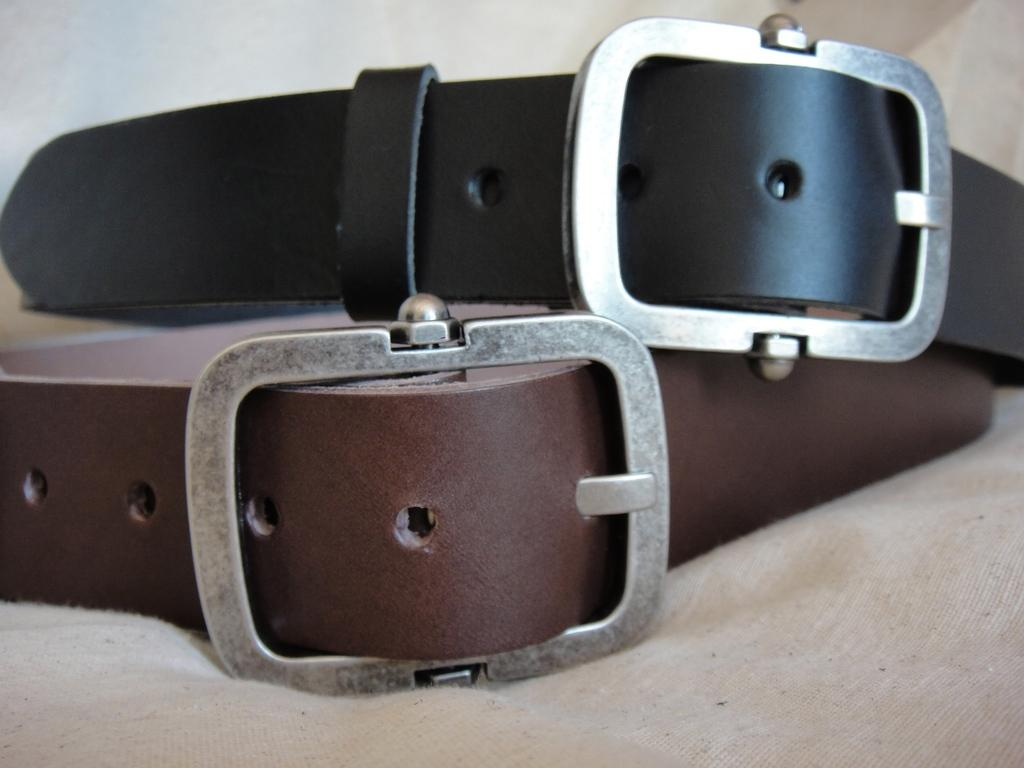What colors are the belts in the image? The belts in the image are brown and black. Where are the belts located in the image? The belts are on a platform. What type of veil is draped over the brown belt in the image? There is no veil present in the image; it only features brown and black belts on a platform. 